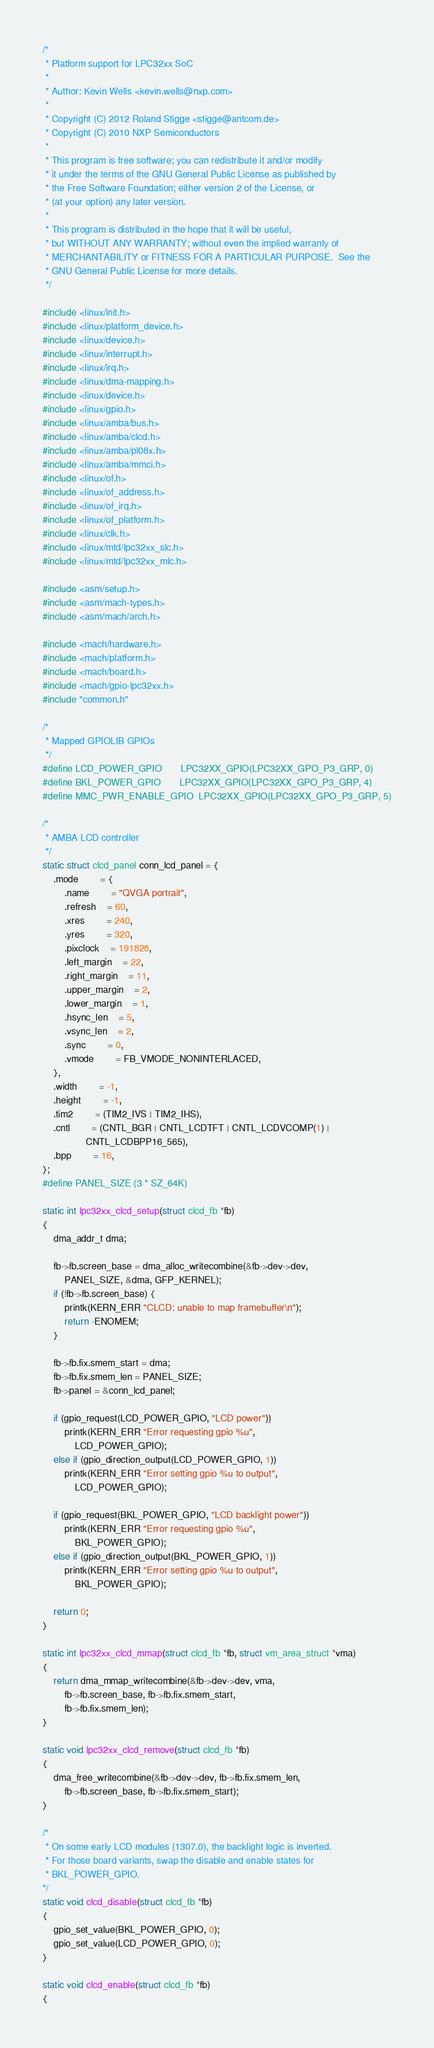Convert code to text. <code><loc_0><loc_0><loc_500><loc_500><_C_>/*
 * Platform support for LPC32xx SoC
 *
 * Author: Kevin Wells <kevin.wells@nxp.com>
 *
 * Copyright (C) 2012 Roland Stigge <stigge@antcom.de>
 * Copyright (C) 2010 NXP Semiconductors
 *
 * This program is free software; you can redistribute it and/or modify
 * it under the terms of the GNU General Public License as published by
 * the Free Software Foundation; either version 2 of the License, or
 * (at your option) any later version.
 *
 * This program is distributed in the hope that it will be useful,
 * but WITHOUT ANY WARRANTY; without even the implied warranty of
 * MERCHANTABILITY or FITNESS FOR A PARTICULAR PURPOSE.  See the
 * GNU General Public License for more details.
 */

#include <linux/init.h>
#include <linux/platform_device.h>
#include <linux/device.h>
#include <linux/interrupt.h>
#include <linux/irq.h>
#include <linux/dma-mapping.h>
#include <linux/device.h>
#include <linux/gpio.h>
#include <linux/amba/bus.h>
#include <linux/amba/clcd.h>
#include <linux/amba/pl08x.h>
#include <linux/amba/mmci.h>
#include <linux/of.h>
#include <linux/of_address.h>
#include <linux/of_irq.h>
#include <linux/of_platform.h>
#include <linux/clk.h>
#include <linux/mtd/lpc32xx_slc.h>
#include <linux/mtd/lpc32xx_mlc.h>

#include <asm/setup.h>
#include <asm/mach-types.h>
#include <asm/mach/arch.h>

#include <mach/hardware.h>
#include <mach/platform.h>
#include <mach/board.h>
#include <mach/gpio-lpc32xx.h>
#include "common.h"

/*
 * Mapped GPIOLIB GPIOs
 */
#define LCD_POWER_GPIO		LPC32XX_GPIO(LPC32XX_GPO_P3_GRP, 0)
#define BKL_POWER_GPIO		LPC32XX_GPIO(LPC32XX_GPO_P3_GRP, 4)
#define MMC_PWR_ENABLE_GPIO	LPC32XX_GPIO(LPC32XX_GPO_P3_GRP, 5)

/*
 * AMBA LCD controller
 */
static struct clcd_panel conn_lcd_panel = {
	.mode		= {
		.name		= "QVGA portrait",
		.refresh	= 60,
		.xres		= 240,
		.yres		= 320,
		.pixclock	= 191828,
		.left_margin	= 22,
		.right_margin	= 11,
		.upper_margin	= 2,
		.lower_margin	= 1,
		.hsync_len	= 5,
		.vsync_len	= 2,
		.sync		= 0,
		.vmode		= FB_VMODE_NONINTERLACED,
	},
	.width		= -1,
	.height		= -1,
	.tim2		= (TIM2_IVS | TIM2_IHS),
	.cntl		= (CNTL_BGR | CNTL_LCDTFT | CNTL_LCDVCOMP(1) |
				CNTL_LCDBPP16_565),
	.bpp		= 16,
};
#define PANEL_SIZE (3 * SZ_64K)

static int lpc32xx_clcd_setup(struct clcd_fb *fb)
{
	dma_addr_t dma;

	fb->fb.screen_base = dma_alloc_writecombine(&fb->dev->dev,
		PANEL_SIZE, &dma, GFP_KERNEL);
	if (!fb->fb.screen_base) {
		printk(KERN_ERR "CLCD: unable to map framebuffer\n");
		return -ENOMEM;
	}

	fb->fb.fix.smem_start = dma;
	fb->fb.fix.smem_len = PANEL_SIZE;
	fb->panel = &conn_lcd_panel;

	if (gpio_request(LCD_POWER_GPIO, "LCD power"))
		printk(KERN_ERR "Error requesting gpio %u",
			LCD_POWER_GPIO);
	else if (gpio_direction_output(LCD_POWER_GPIO, 1))
		printk(KERN_ERR "Error setting gpio %u to output",
			LCD_POWER_GPIO);

	if (gpio_request(BKL_POWER_GPIO, "LCD backlight power"))
		printk(KERN_ERR "Error requesting gpio %u",
			BKL_POWER_GPIO);
	else if (gpio_direction_output(BKL_POWER_GPIO, 1))
		printk(KERN_ERR "Error setting gpio %u to output",
			BKL_POWER_GPIO);

	return 0;
}

static int lpc32xx_clcd_mmap(struct clcd_fb *fb, struct vm_area_struct *vma)
{
	return dma_mmap_writecombine(&fb->dev->dev, vma,
		fb->fb.screen_base, fb->fb.fix.smem_start,
		fb->fb.fix.smem_len);
}

static void lpc32xx_clcd_remove(struct clcd_fb *fb)
{
	dma_free_writecombine(&fb->dev->dev, fb->fb.fix.smem_len,
		fb->fb.screen_base, fb->fb.fix.smem_start);
}

/*
 * On some early LCD modules (1307.0), the backlight logic is inverted.
 * For those board variants, swap the disable and enable states for
 * BKL_POWER_GPIO.
*/
static void clcd_disable(struct clcd_fb *fb)
{
	gpio_set_value(BKL_POWER_GPIO, 0);
	gpio_set_value(LCD_POWER_GPIO, 0);
}

static void clcd_enable(struct clcd_fb *fb)
{</code> 